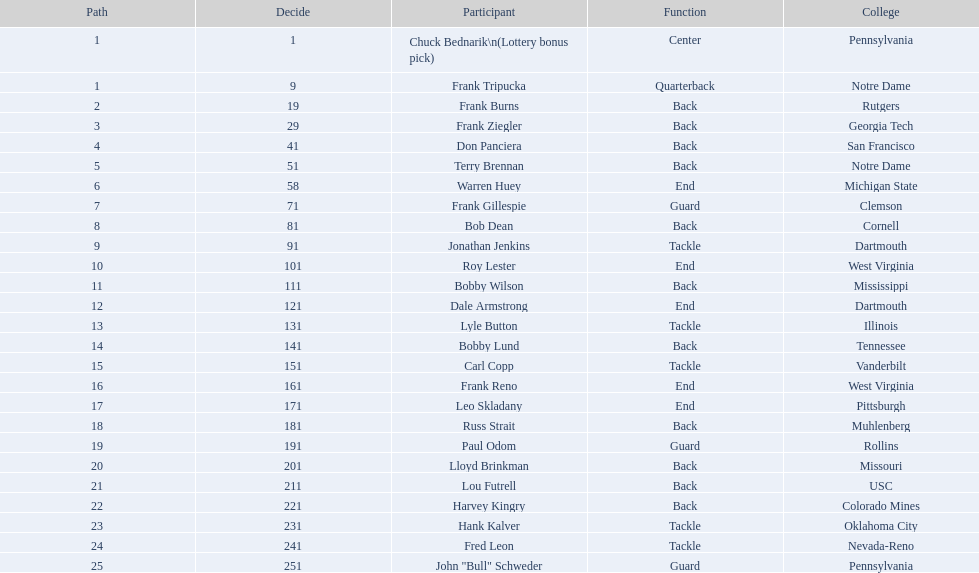What is the highest number in rd? 25. 